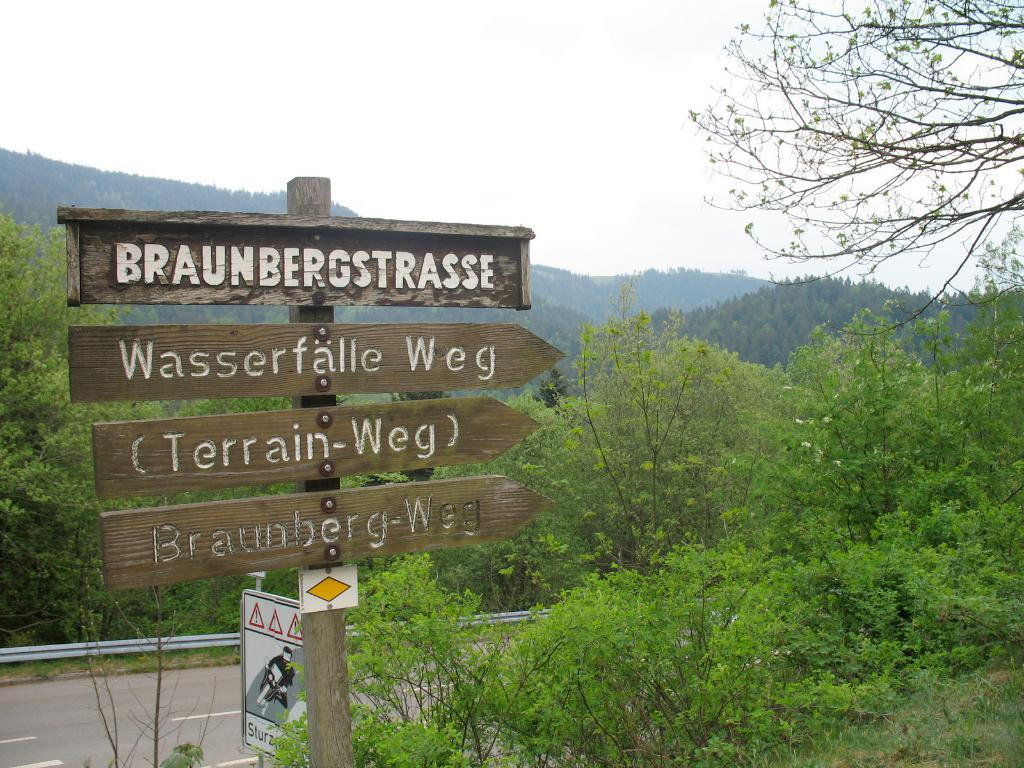What is attached to the pole in the image? There are sign boards attached to a pole in the image. Where are the sign boards located in relation to other objects? The sign boards are near plants and a road. What can be seen in the background of the image? There are trees, mountains, and the sky visible in the background of the image. Can you see a boat in the front of the image? There is no boat present in the image. What type of grass is growing near the sign boards? There is no grass visible near the sign boards in the image. 